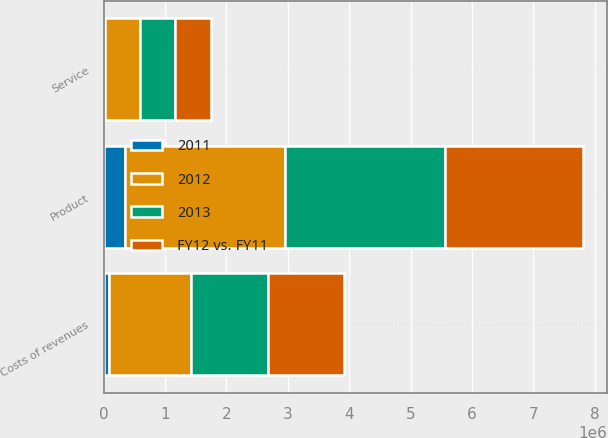Convert chart. <chart><loc_0><loc_0><loc_500><loc_500><stacked_bar_chart><ecel><fcel>Product<fcel>Service<fcel>Costs of revenues<nl><fcel>FY12 vs. FY11<fcel>2.24715e+06<fcel>595634<fcel>1.23745e+06<nl><fcel>2012<fcel>2.59776e+06<fcel>574189<fcel>1.33002e+06<nl><fcel>2013<fcel>2.61344e+06<fcel>561729<fcel>1.25924e+06<nl><fcel>2011<fcel>350608<fcel>21445<fcel>92564<nl></chart> 